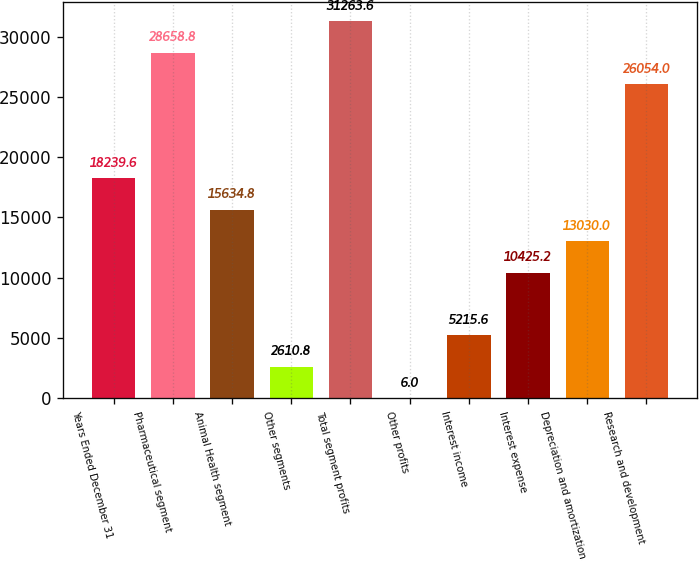Convert chart to OTSL. <chart><loc_0><loc_0><loc_500><loc_500><bar_chart><fcel>Years Ended December 31<fcel>Pharmaceutical segment<fcel>Animal Health segment<fcel>Other segments<fcel>Total segment profits<fcel>Other profits<fcel>Interest income<fcel>Interest expense<fcel>Depreciation and amortization<fcel>Research and development<nl><fcel>18239.6<fcel>28658.8<fcel>15634.8<fcel>2610.8<fcel>31263.6<fcel>6<fcel>5215.6<fcel>10425.2<fcel>13030<fcel>26054<nl></chart> 